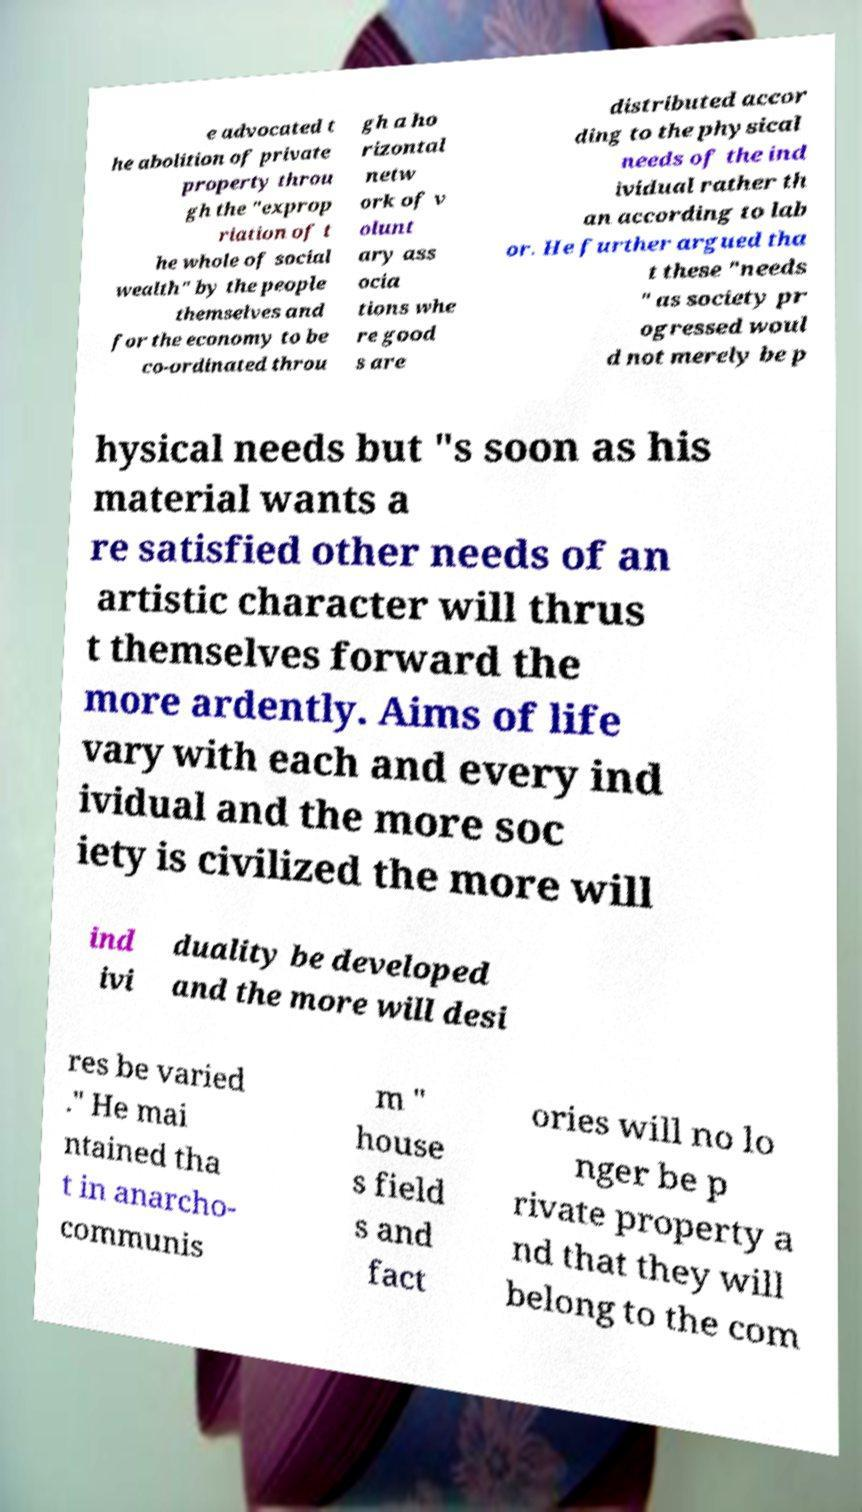Can you read and provide the text displayed in the image?This photo seems to have some interesting text. Can you extract and type it out for me? e advocated t he abolition of private property throu gh the "exprop riation of t he whole of social wealth" by the people themselves and for the economy to be co-ordinated throu gh a ho rizontal netw ork of v olunt ary ass ocia tions whe re good s are distributed accor ding to the physical needs of the ind ividual rather th an according to lab or. He further argued tha t these "needs " as society pr ogressed woul d not merely be p hysical needs but "s soon as his material wants a re satisfied other needs of an artistic character will thrus t themselves forward the more ardently. Aims of life vary with each and every ind ividual and the more soc iety is civilized the more will ind ivi duality be developed and the more will desi res be varied ." He mai ntained tha t in anarcho- communis m " house s field s and fact ories will no lo nger be p rivate property a nd that they will belong to the com 